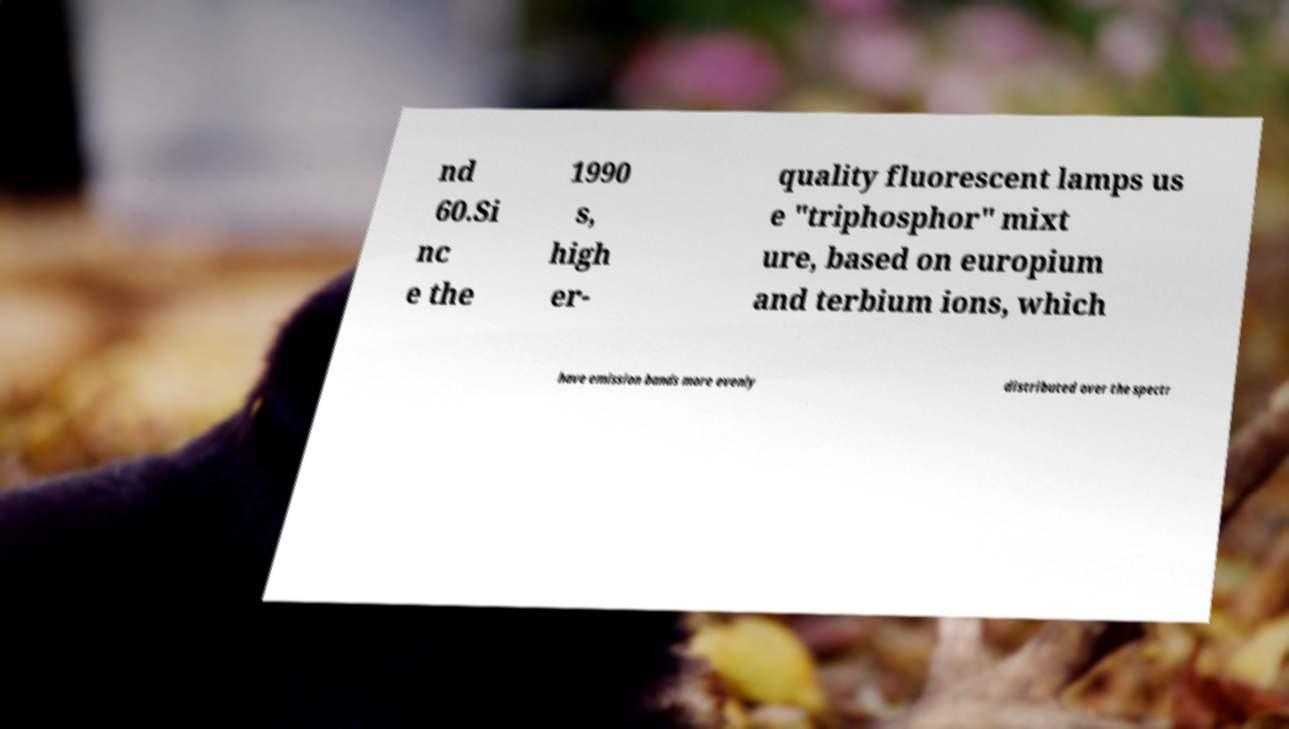What messages or text are displayed in this image? I need them in a readable, typed format. nd 60.Si nc e the 1990 s, high er- quality fluorescent lamps us e "triphosphor" mixt ure, based on europium and terbium ions, which have emission bands more evenly distributed over the spectr 